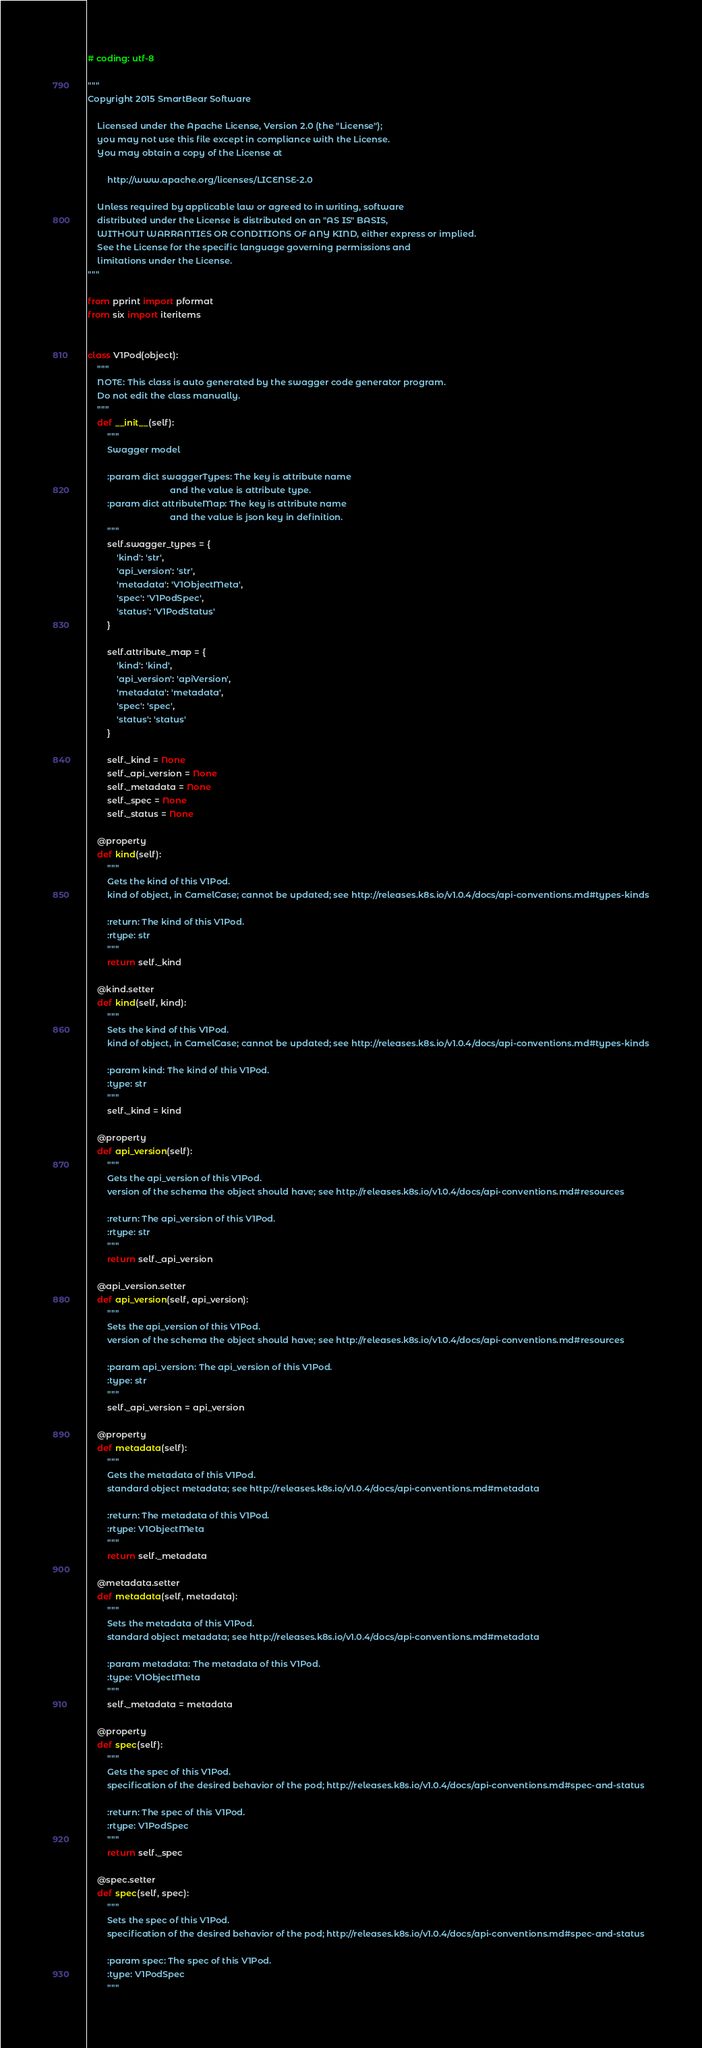Convert code to text. <code><loc_0><loc_0><loc_500><loc_500><_Python_># coding: utf-8

"""
Copyright 2015 SmartBear Software

    Licensed under the Apache License, Version 2.0 (the "License");
    you may not use this file except in compliance with the License.
    You may obtain a copy of the License at

        http://www.apache.org/licenses/LICENSE-2.0

    Unless required by applicable law or agreed to in writing, software
    distributed under the License is distributed on an "AS IS" BASIS,
    WITHOUT WARRANTIES OR CONDITIONS OF ANY KIND, either express or implied.
    See the License for the specific language governing permissions and
    limitations under the License.
"""

from pprint import pformat
from six import iteritems


class V1Pod(object):
    """
    NOTE: This class is auto generated by the swagger code generator program.
    Do not edit the class manually.
    """
    def __init__(self):
        """
        Swagger model

        :param dict swaggerTypes: The key is attribute name
                                  and the value is attribute type.
        :param dict attributeMap: The key is attribute name
                                  and the value is json key in definition.
        """
        self.swagger_types = {
            'kind': 'str',
            'api_version': 'str',
            'metadata': 'V1ObjectMeta',
            'spec': 'V1PodSpec',
            'status': 'V1PodStatus'
        }

        self.attribute_map = {
            'kind': 'kind',
            'api_version': 'apiVersion',
            'metadata': 'metadata',
            'spec': 'spec',
            'status': 'status'
        }

        self._kind = None
        self._api_version = None
        self._metadata = None
        self._spec = None
        self._status = None

    @property
    def kind(self):
        """
        Gets the kind of this V1Pod.
        kind of object, in CamelCase; cannot be updated; see http://releases.k8s.io/v1.0.4/docs/api-conventions.md#types-kinds

        :return: The kind of this V1Pod.
        :rtype: str
        """
        return self._kind

    @kind.setter
    def kind(self, kind):
        """
        Sets the kind of this V1Pod.
        kind of object, in CamelCase; cannot be updated; see http://releases.k8s.io/v1.0.4/docs/api-conventions.md#types-kinds

        :param kind: The kind of this V1Pod.
        :type: str
        """
        self._kind = kind

    @property
    def api_version(self):
        """
        Gets the api_version of this V1Pod.
        version of the schema the object should have; see http://releases.k8s.io/v1.0.4/docs/api-conventions.md#resources

        :return: The api_version of this V1Pod.
        :rtype: str
        """
        return self._api_version

    @api_version.setter
    def api_version(self, api_version):
        """
        Sets the api_version of this V1Pod.
        version of the schema the object should have; see http://releases.k8s.io/v1.0.4/docs/api-conventions.md#resources

        :param api_version: The api_version of this V1Pod.
        :type: str
        """
        self._api_version = api_version

    @property
    def metadata(self):
        """
        Gets the metadata of this V1Pod.
        standard object metadata; see http://releases.k8s.io/v1.0.4/docs/api-conventions.md#metadata

        :return: The metadata of this V1Pod.
        :rtype: V1ObjectMeta
        """
        return self._metadata

    @metadata.setter
    def metadata(self, metadata):
        """
        Sets the metadata of this V1Pod.
        standard object metadata; see http://releases.k8s.io/v1.0.4/docs/api-conventions.md#metadata

        :param metadata: The metadata of this V1Pod.
        :type: V1ObjectMeta
        """
        self._metadata = metadata

    @property
    def spec(self):
        """
        Gets the spec of this V1Pod.
        specification of the desired behavior of the pod; http://releases.k8s.io/v1.0.4/docs/api-conventions.md#spec-and-status

        :return: The spec of this V1Pod.
        :rtype: V1PodSpec
        """
        return self._spec

    @spec.setter
    def spec(self, spec):
        """
        Sets the spec of this V1Pod.
        specification of the desired behavior of the pod; http://releases.k8s.io/v1.0.4/docs/api-conventions.md#spec-and-status

        :param spec: The spec of this V1Pod.
        :type: V1PodSpec
        """</code> 